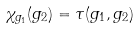<formula> <loc_0><loc_0><loc_500><loc_500>\chi _ { g _ { 1 } } ( g _ { 2 } ) = \tau ( g _ { 1 } , g _ { 2 } )</formula> 